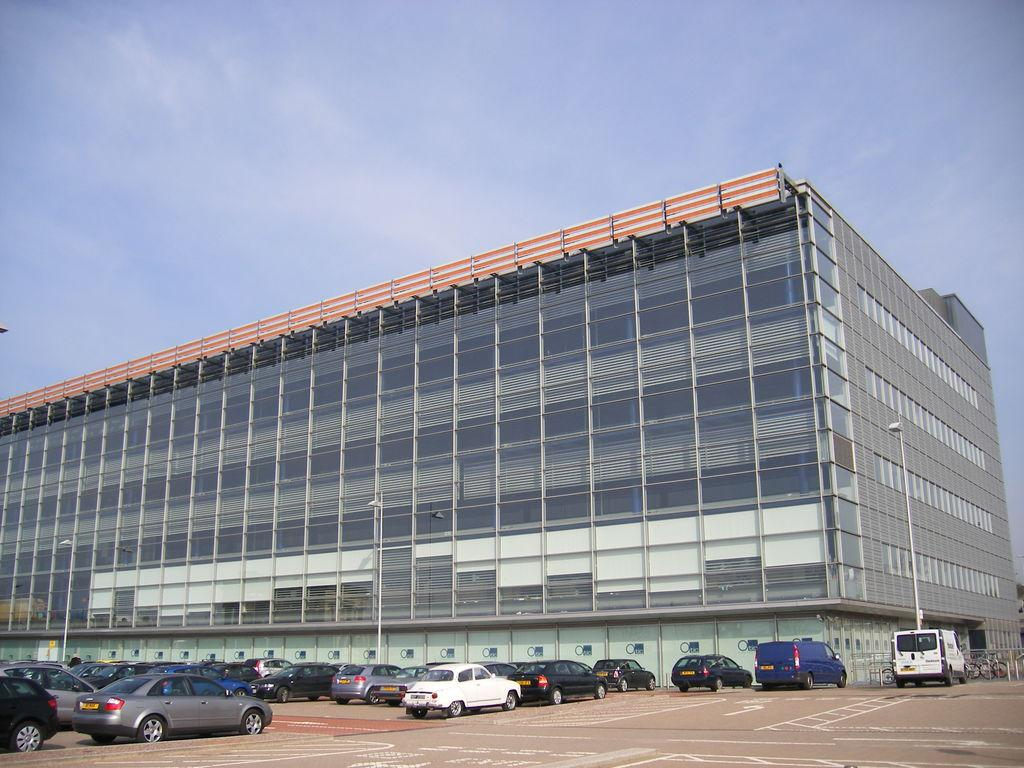What types of transportation are present on the ground in the image? There are vehicles on the ground in the image. What kind of barrier can be seen in the image? There is a fence in the image. What mode of transportation can be seen in addition to vehicles? There are bicycles in the image. What type of structure is visible in the image? There is a building in the image. What can be seen in the background of the image? The sky with clouds is visible in the background of the image. What is the most efficient route to take on the stretch of road depicted in the image? There is no stretch of road or route mentioned in the image, as it features vehicles, a fence, bicycles, a building, and a sky with clouds. 